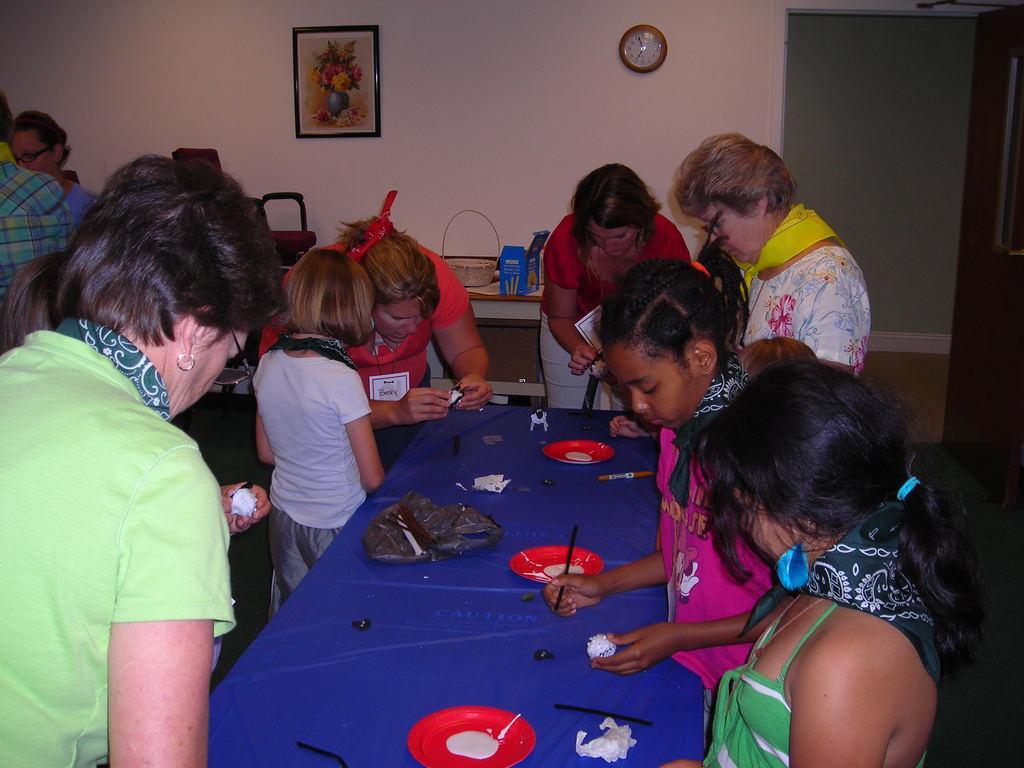Could you give a brief overview of what you see in this image? As we can see in the image there is a wall, photo frame, clock and few people standing here and there and there is a table. On table there is a plate. 